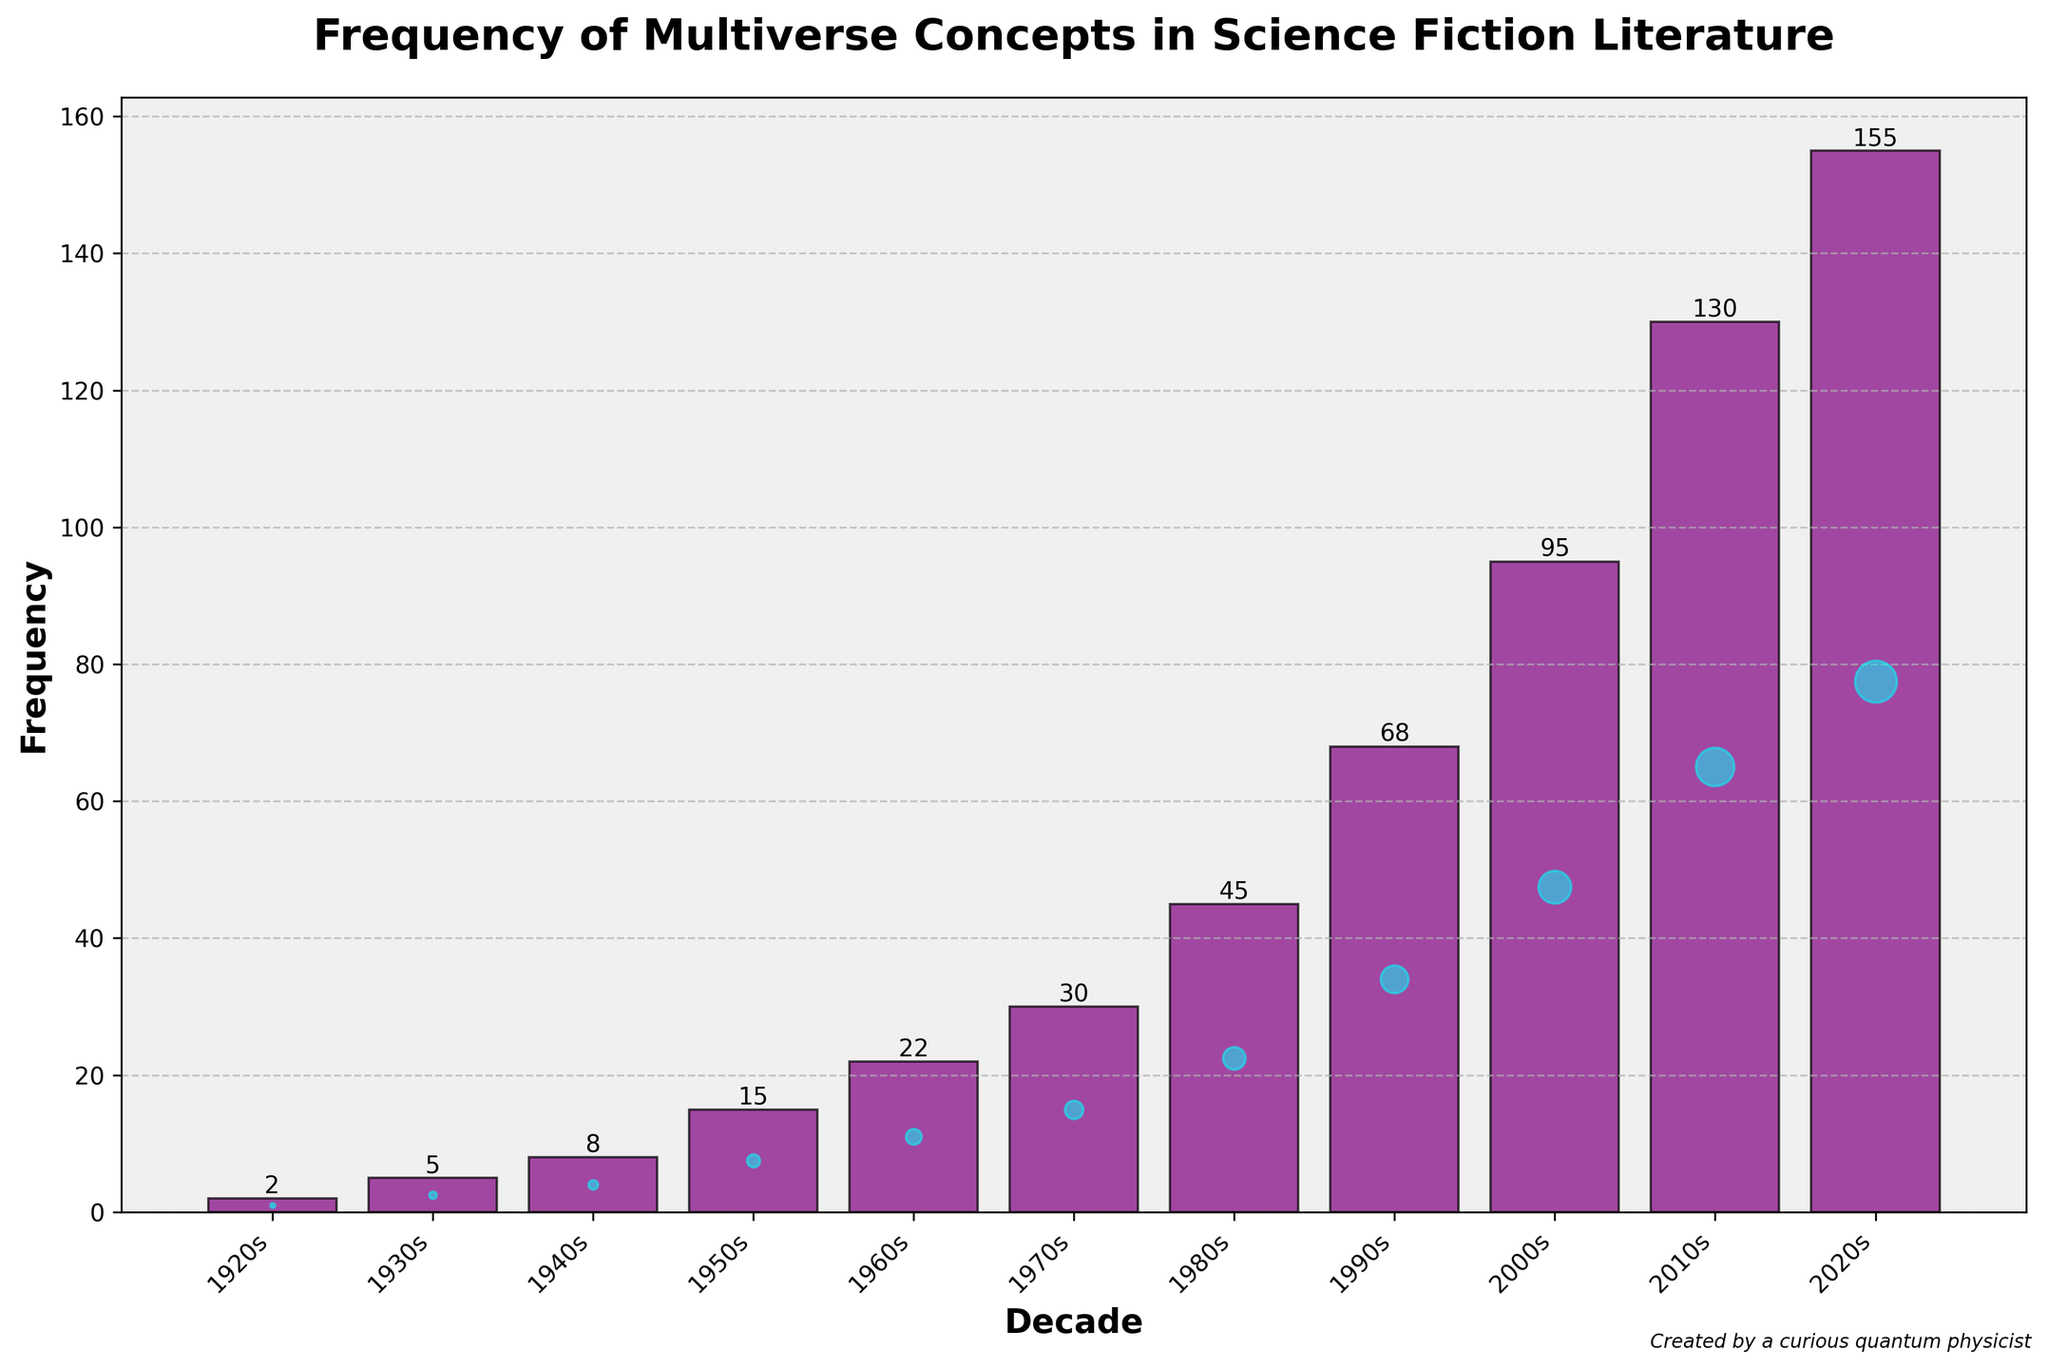Which decade saw the highest frequency of multiverse concepts in science fiction literature? The highest bar in the chart corresponds to the 2020s with a frequency of 155.
Answer: 2020s How many more multiverse concepts were introduced in the 2000s compared to the 1940s? The frequency in the 2000s was 95, and in the 1940s it was 8. So, the difference is 95 - 8 = 87.
Answer: 87 In which decade did the frequency of multiverse concepts first exceed 20? The chart shows that the frequency first exceeded 20 in the 1960s, with a frequency of 22.
Answer: 1960s What's the sum of the frequencies of multiverse concepts from the 1980s and 1990s? The frequency in the 1980s is 45 and in the 1990s is 68. Summing these values gives 45 + 68 = 113.
Answer: 113 How much higher is the frequency of multiverse concepts in the 2020s compared to the 1950s? The frequency in the 2020s is 155, and in the 1950s it is 15, so the difference is 155 - 15 = 140.
Answer: 140 Which decade had a frequency of multiverse concepts that is exactly double the frequency in the 1940s? The frequency in the 1940s is 8. Doubling this gives 8 * 2 = 16, but no decade has exactly this frequency. The closest is the 1950s with a frequency of 15.
Answer: None What is the average frequency of multiverse concepts in the first four decades (1920s-1950s)? The frequencies for the 1920s-1950s are 2, 5, 8, and 15. Their sum is 2 + 5 + 8 + 15 = 30, and the average is 30 / 4 = 7.5.
Answer: 7.5 By how much did the frequency of multiverse concepts increase from the 1970s to the 2010s? The frequency in the 1970s is 30, and in the 2010s it is 130. The increase is 130 - 30 = 100.
Answer: 100 Which two consecutive decades showed the largest increase in the frequency of multiverse concepts? The largest increase occurred between the 2010s and the 2020s with an increase of 155 - 130 = 25.
Answer: 2010s to 2020s 